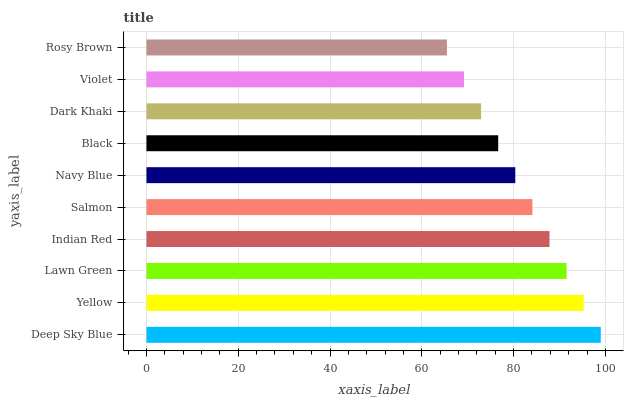Is Rosy Brown the minimum?
Answer yes or no. Yes. Is Deep Sky Blue the maximum?
Answer yes or no. Yes. Is Yellow the minimum?
Answer yes or no. No. Is Yellow the maximum?
Answer yes or no. No. Is Deep Sky Blue greater than Yellow?
Answer yes or no. Yes. Is Yellow less than Deep Sky Blue?
Answer yes or no. Yes. Is Yellow greater than Deep Sky Blue?
Answer yes or no. No. Is Deep Sky Blue less than Yellow?
Answer yes or no. No. Is Salmon the high median?
Answer yes or no. Yes. Is Navy Blue the low median?
Answer yes or no. Yes. Is Dark Khaki the high median?
Answer yes or no. No. Is Violet the low median?
Answer yes or no. No. 